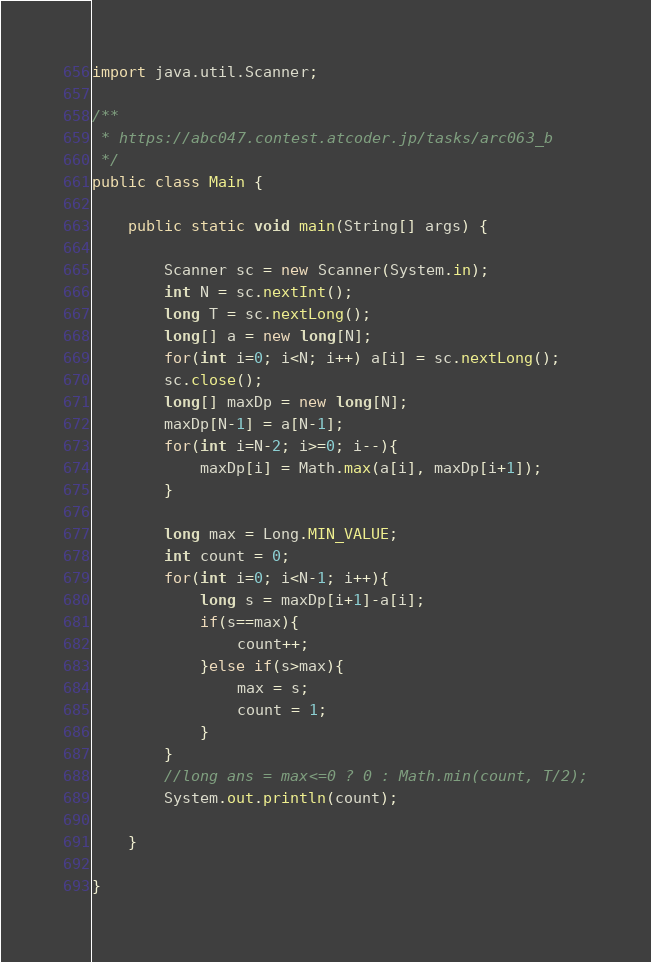<code> <loc_0><loc_0><loc_500><loc_500><_Java_>import java.util.Scanner;

/**
 * https://abc047.contest.atcoder.jp/tasks/arc063_b
 */
public class Main {

	public static void main(String[] args) {
		
		Scanner sc = new Scanner(System.in);
		int N = sc.nextInt();
		long T = sc.nextLong();
		long[] a = new long[N];
		for(int i=0; i<N; i++) a[i] = sc.nextLong();
		sc.close();
		long[] maxDp = new long[N];
		maxDp[N-1] = a[N-1];
		for(int i=N-2; i>=0; i--){
			maxDp[i] = Math.max(a[i], maxDp[i+1]);
		}
		
		long max = Long.MIN_VALUE;
		int count = 0;
		for(int i=0; i<N-1; i++){
			long s = maxDp[i+1]-a[i];
			if(s==max){
				count++;
			}else if(s>max){
				max = s;
				count = 1;
			}
		}
		//long ans = max<=0 ? 0 : Math.min(count, T/2);
		System.out.println(count);

	}

}</code> 